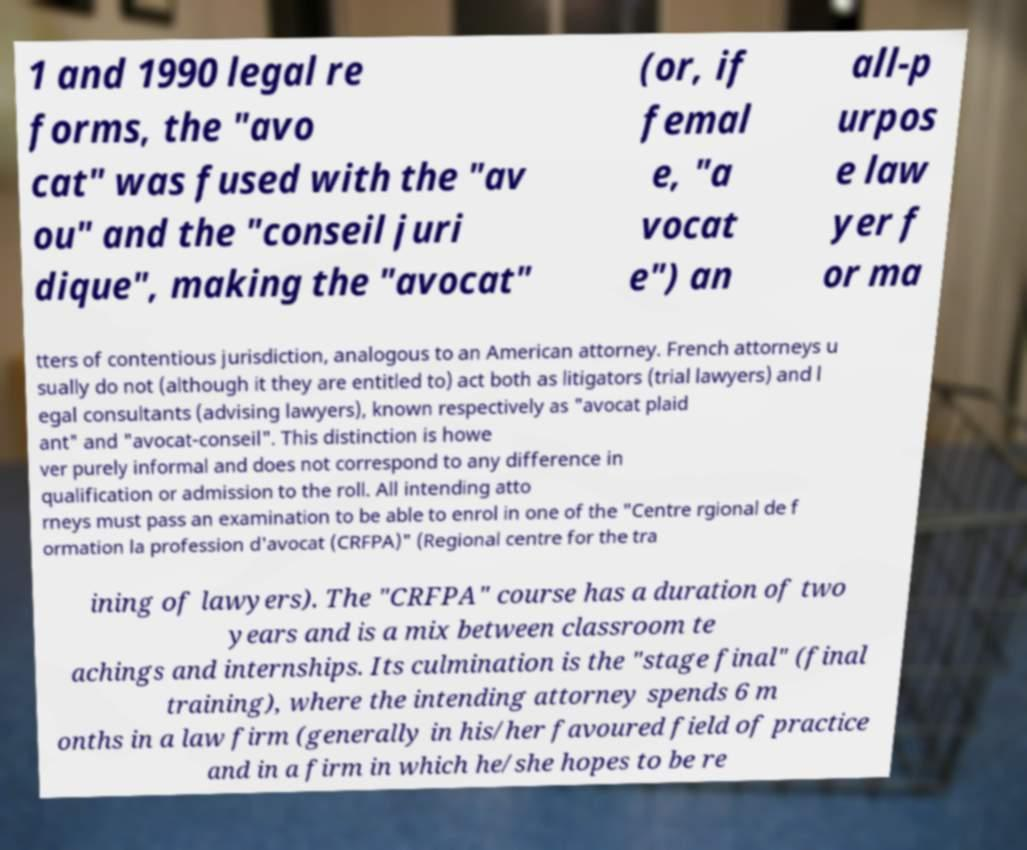Please read and relay the text visible in this image. What does it say? 1 and 1990 legal re forms, the "avo cat" was fused with the "av ou" and the "conseil juri dique", making the "avocat" (or, if femal e, "a vocat e") an all-p urpos e law yer f or ma tters of contentious jurisdiction, analogous to an American attorney. French attorneys u sually do not (although it they are entitled to) act both as litigators (trial lawyers) and l egal consultants (advising lawyers), known respectively as "avocat plaid ant" and "avocat-conseil". This distinction is howe ver purely informal and does not correspond to any difference in qualification or admission to the roll. All intending atto rneys must pass an examination to be able to enrol in one of the "Centre rgional de f ormation la profession d'avocat (CRFPA)" (Regional centre for the tra ining of lawyers). The "CRFPA" course has a duration of two years and is a mix between classroom te achings and internships. Its culmination is the "stage final" (final training), where the intending attorney spends 6 m onths in a law firm (generally in his/her favoured field of practice and in a firm in which he/she hopes to be re 